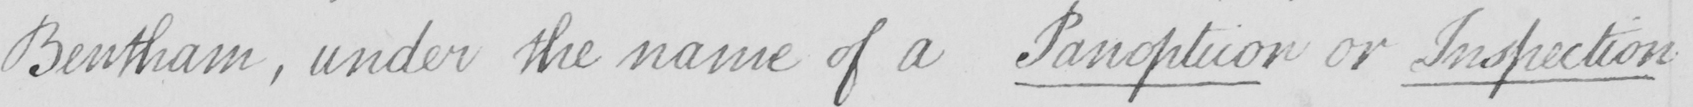What is written in this line of handwriting? Bentham , under the name of a Panopticon or Inspection 